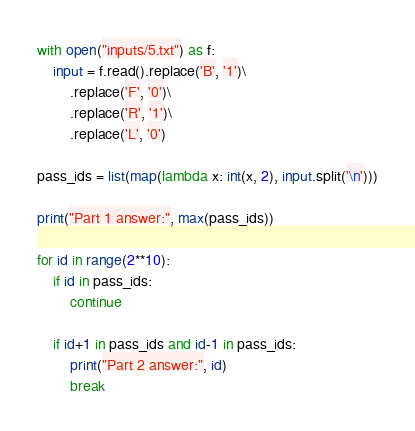<code> <loc_0><loc_0><loc_500><loc_500><_Python_>with open("inputs/5.txt") as f:
    input = f.read().replace('B', '1')\
        .replace('F', '0')\
        .replace('R', '1')\
        .replace('L', '0')

pass_ids = list(map(lambda x: int(x, 2), input.split('\n')))

print("Part 1 answer:", max(pass_ids))

for id in range(2**10):
    if id in pass_ids:
        continue

    if id+1 in pass_ids and id-1 in pass_ids:
        print("Part 2 answer:", id)
        break</code> 